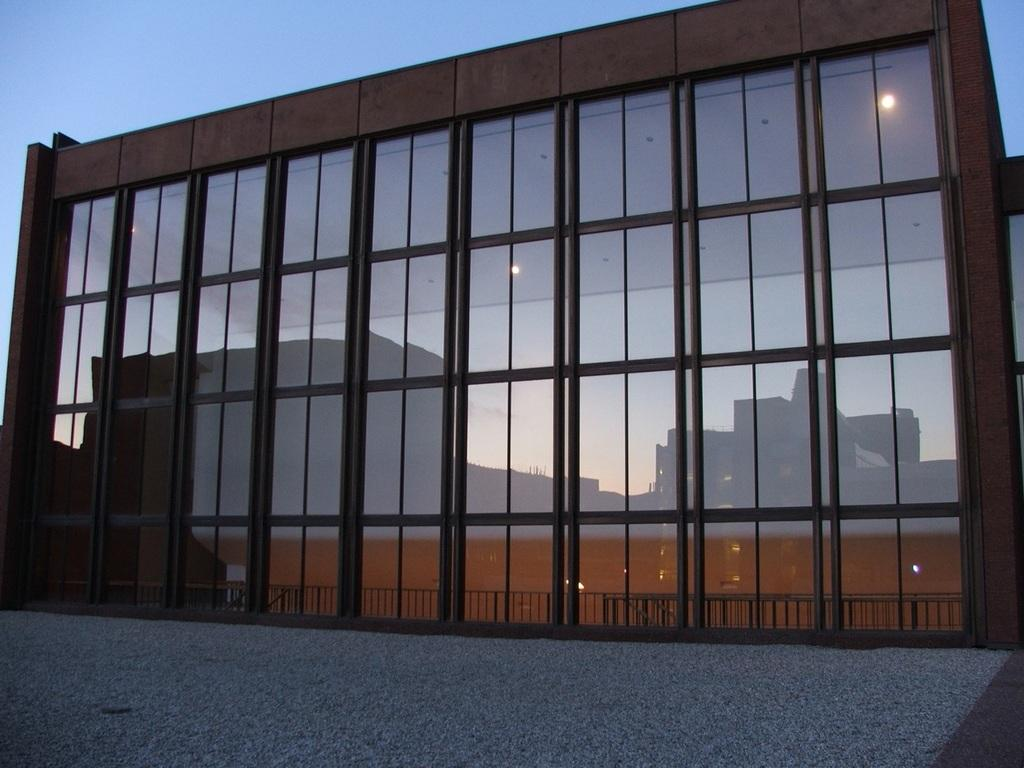What type of structure is present in the image? There is a building in the image. What objects can be seen inside the building? There are glasses visible in the image. What part of the interior can be seen in the image? The floor is visible in the image. What part of the natural environment is visible in the image? The sky is visible in the image. What is the value of the hand in the image? There is no hand present in the image, so it is not possible to determine its value. 